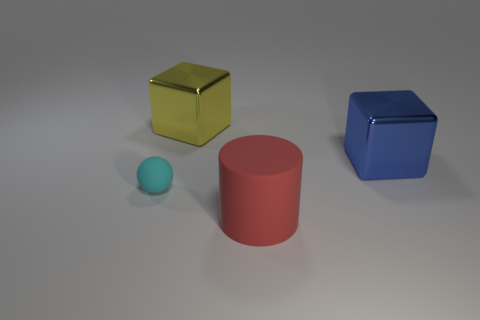There is a thing that is in front of the big blue thing and behind the cylinder; what is its shape?
Provide a succinct answer. Sphere. There is a large object that is behind the small cyan ball and in front of the yellow metallic object; what is its color?
Give a very brief answer. Blue. Is the number of small matte balls that are on the right side of the ball greater than the number of small cyan rubber things that are on the left side of the blue block?
Your answer should be compact. No. What color is the matte thing that is on the right side of the ball?
Your answer should be very brief. Red. There is a yellow metallic thing that is on the left side of the big blue object; is it the same shape as the large thing that is in front of the big blue metal thing?
Offer a terse response. No. Is there a yellow block that has the same size as the blue shiny thing?
Make the answer very short. Yes. There is a big object that is in front of the tiny ball; what material is it?
Provide a short and direct response. Rubber. Do the cyan ball that is to the left of the large red cylinder and the big yellow cube have the same material?
Make the answer very short. No. Are any big brown matte balls visible?
Your answer should be compact. No. The big block that is made of the same material as the blue object is what color?
Your answer should be compact. Yellow. 